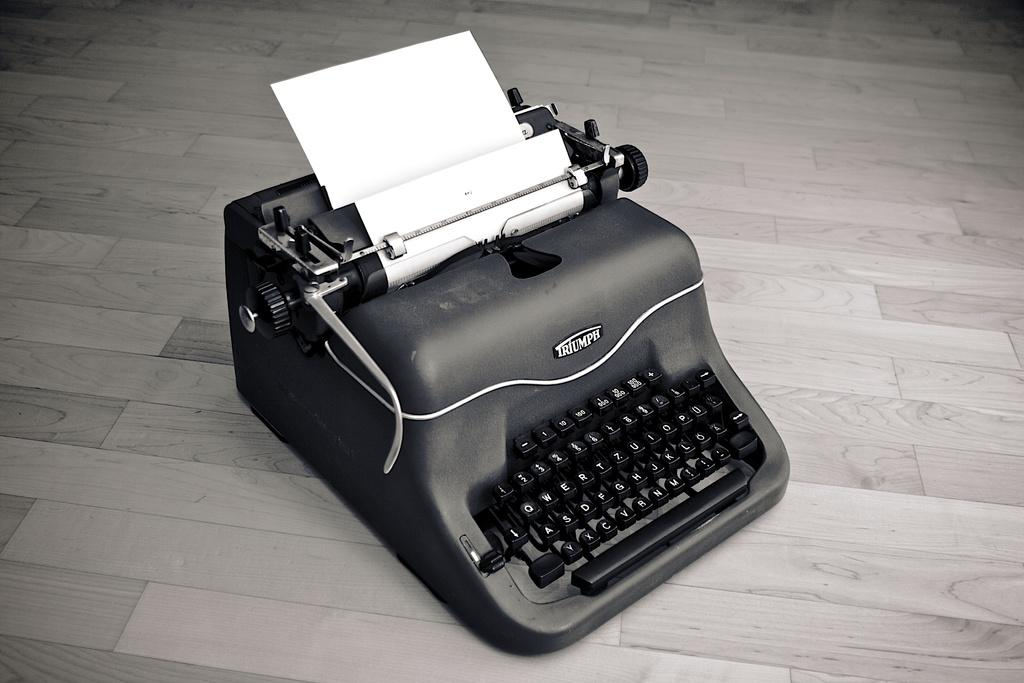<image>
Share a concise interpretation of the image provided. a typewriter with the word triumph on it 